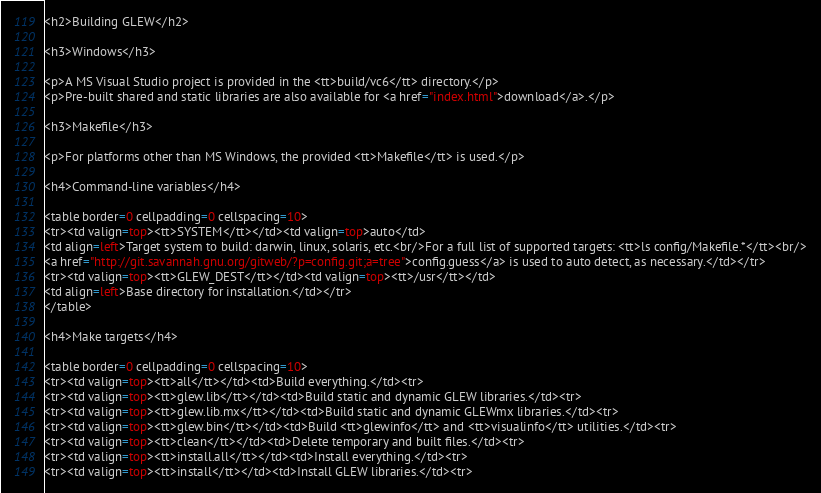<code> <loc_0><loc_0><loc_500><loc_500><_HTML_><h2>Building GLEW</h2>

<h3>Windows</h3>

<p>A MS Visual Studio project is provided in the <tt>build/vc6</tt> directory.</p>
<p>Pre-built shared and static libraries are also available for <a href="index.html">download</a>.</p>

<h3>Makefile</h3>

<p>For platforms other than MS Windows, the provided <tt>Makefile</tt> is used.</p> 

<h4>Command-line variables</h4>

<table border=0 cellpadding=0 cellspacing=10>
<tr><td valign=top><tt>SYSTEM</tt></td><td valign=top>auto</td>
<td align=left>Target system to build: darwin, linux, solaris, etc.<br/>For a full list of supported targets: <tt>ls config/Makefile.*</tt><br/>
<a href="http://git.savannah.gnu.org/gitweb/?p=config.git;a=tree">config.guess</a> is used to auto detect, as necessary.</td></tr>
<tr><td valign=top><tt>GLEW_DEST</tt></td><td valign=top><tt>/usr</tt></td>
<td align=left>Base directory for installation.</td></tr>
</table>

<h4>Make targets</h4>

<table border=0 cellpadding=0 cellspacing=10>
<tr><td valign=top><tt>all</tt></td><td>Build everything.</td><tr>
<tr><td valign=top><tt>glew.lib</tt></td><td>Build static and dynamic GLEW libraries.</td><tr>
<tr><td valign=top><tt>glew.lib.mx</tt></td><td>Build static and dynamic GLEWmx libraries.</td><tr>
<tr><td valign=top><tt>glew.bin</tt></td><td>Build <tt>glewinfo</tt> and <tt>visualinfo</tt> utilities.</td><tr>
<tr><td valign=top><tt>clean</tt></td><td>Delete temporary and built files.</td><tr>
<tr><td valign=top><tt>install.all</tt></td><td>Install everything.</td><tr>
<tr><td valign=top><tt>install</tt></td><td>Install GLEW libraries.</td><tr></code> 